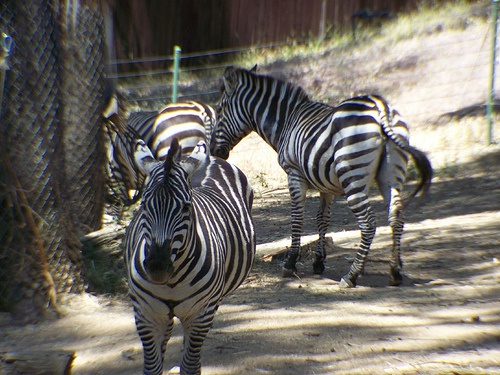Describe the objects in this image and their specific colors. I can see zebra in black, gray, darkgray, and lightgray tones, zebra in black, gray, darkgray, and navy tones, and zebra in black, gray, white, and darkgray tones in this image. 